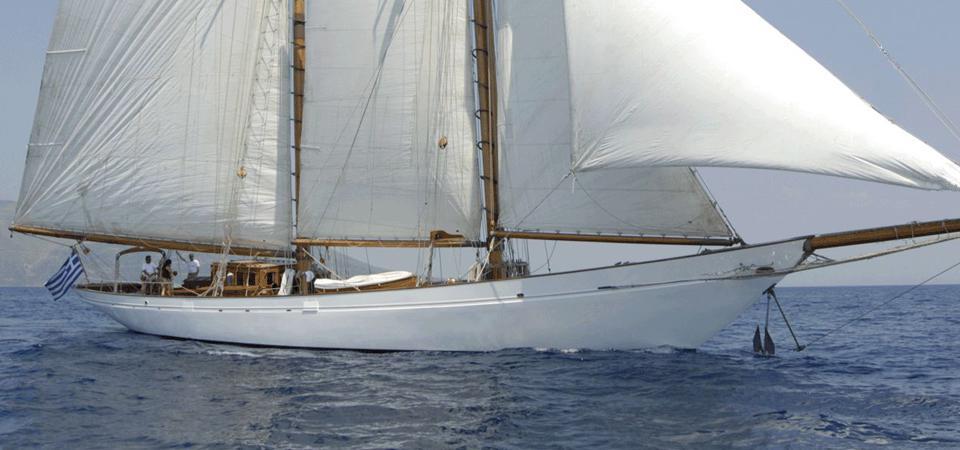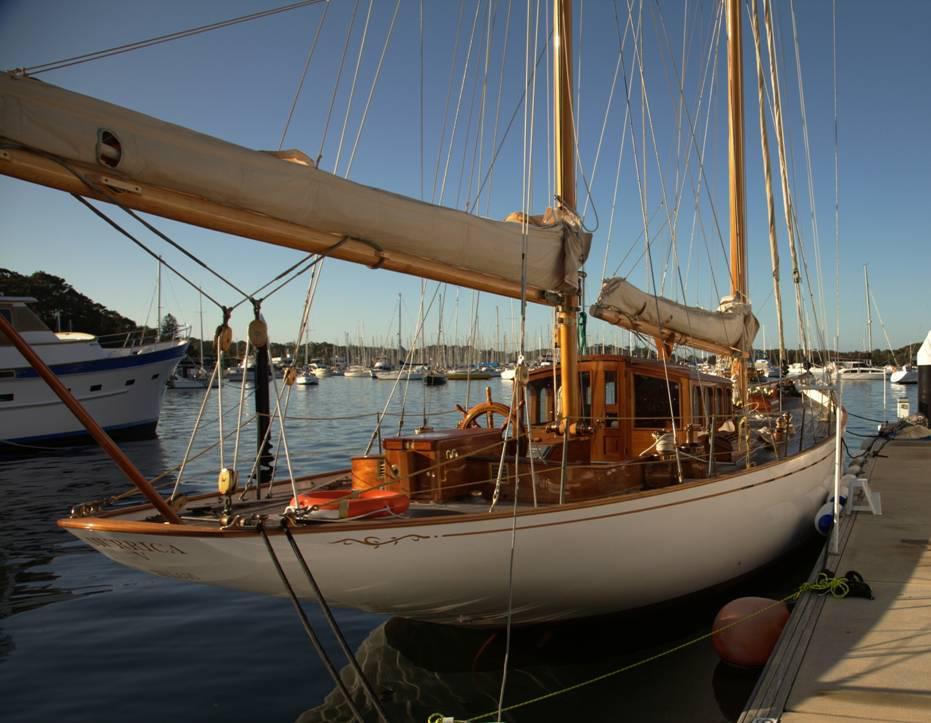The first image is the image on the left, the second image is the image on the right. Assess this claim about the two images: "A sailboat in one image has white billowing sails, but the sails of a boat in the other image are furled.". Correct or not? Answer yes or no. Yes. The first image is the image on the left, the second image is the image on the right. Evaluate the accuracy of this statement regarding the images: "The boat in the left image has a red flag hanging from its rear.". Is it true? Answer yes or no. No. 